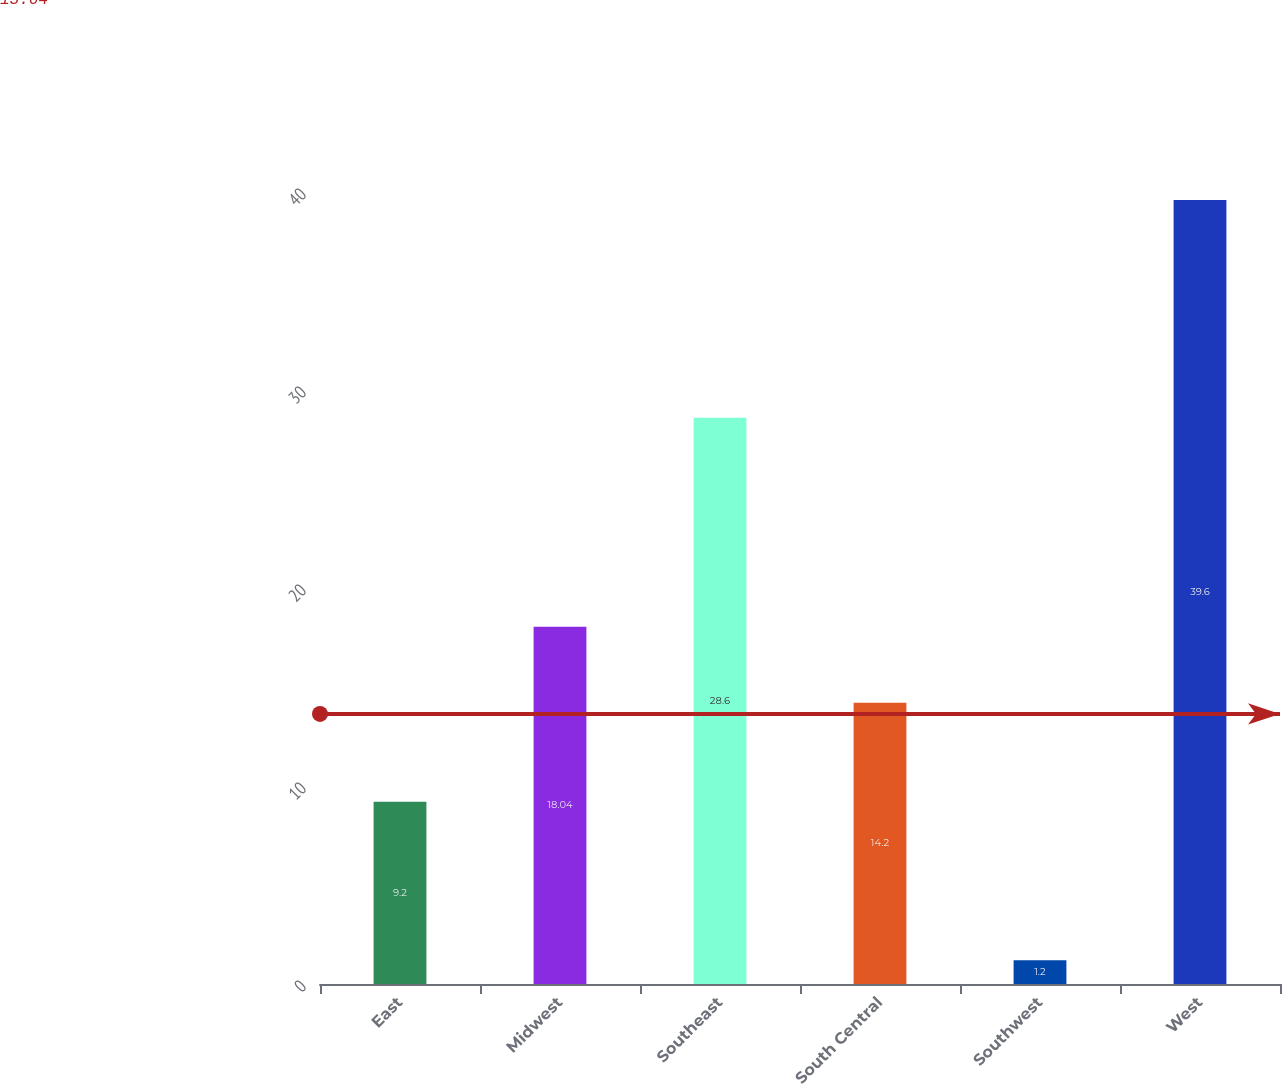Convert chart to OTSL. <chart><loc_0><loc_0><loc_500><loc_500><bar_chart><fcel>East<fcel>Midwest<fcel>Southeast<fcel>South Central<fcel>Southwest<fcel>West<nl><fcel>9.2<fcel>18.04<fcel>28.6<fcel>14.2<fcel>1.2<fcel>39.6<nl></chart> 